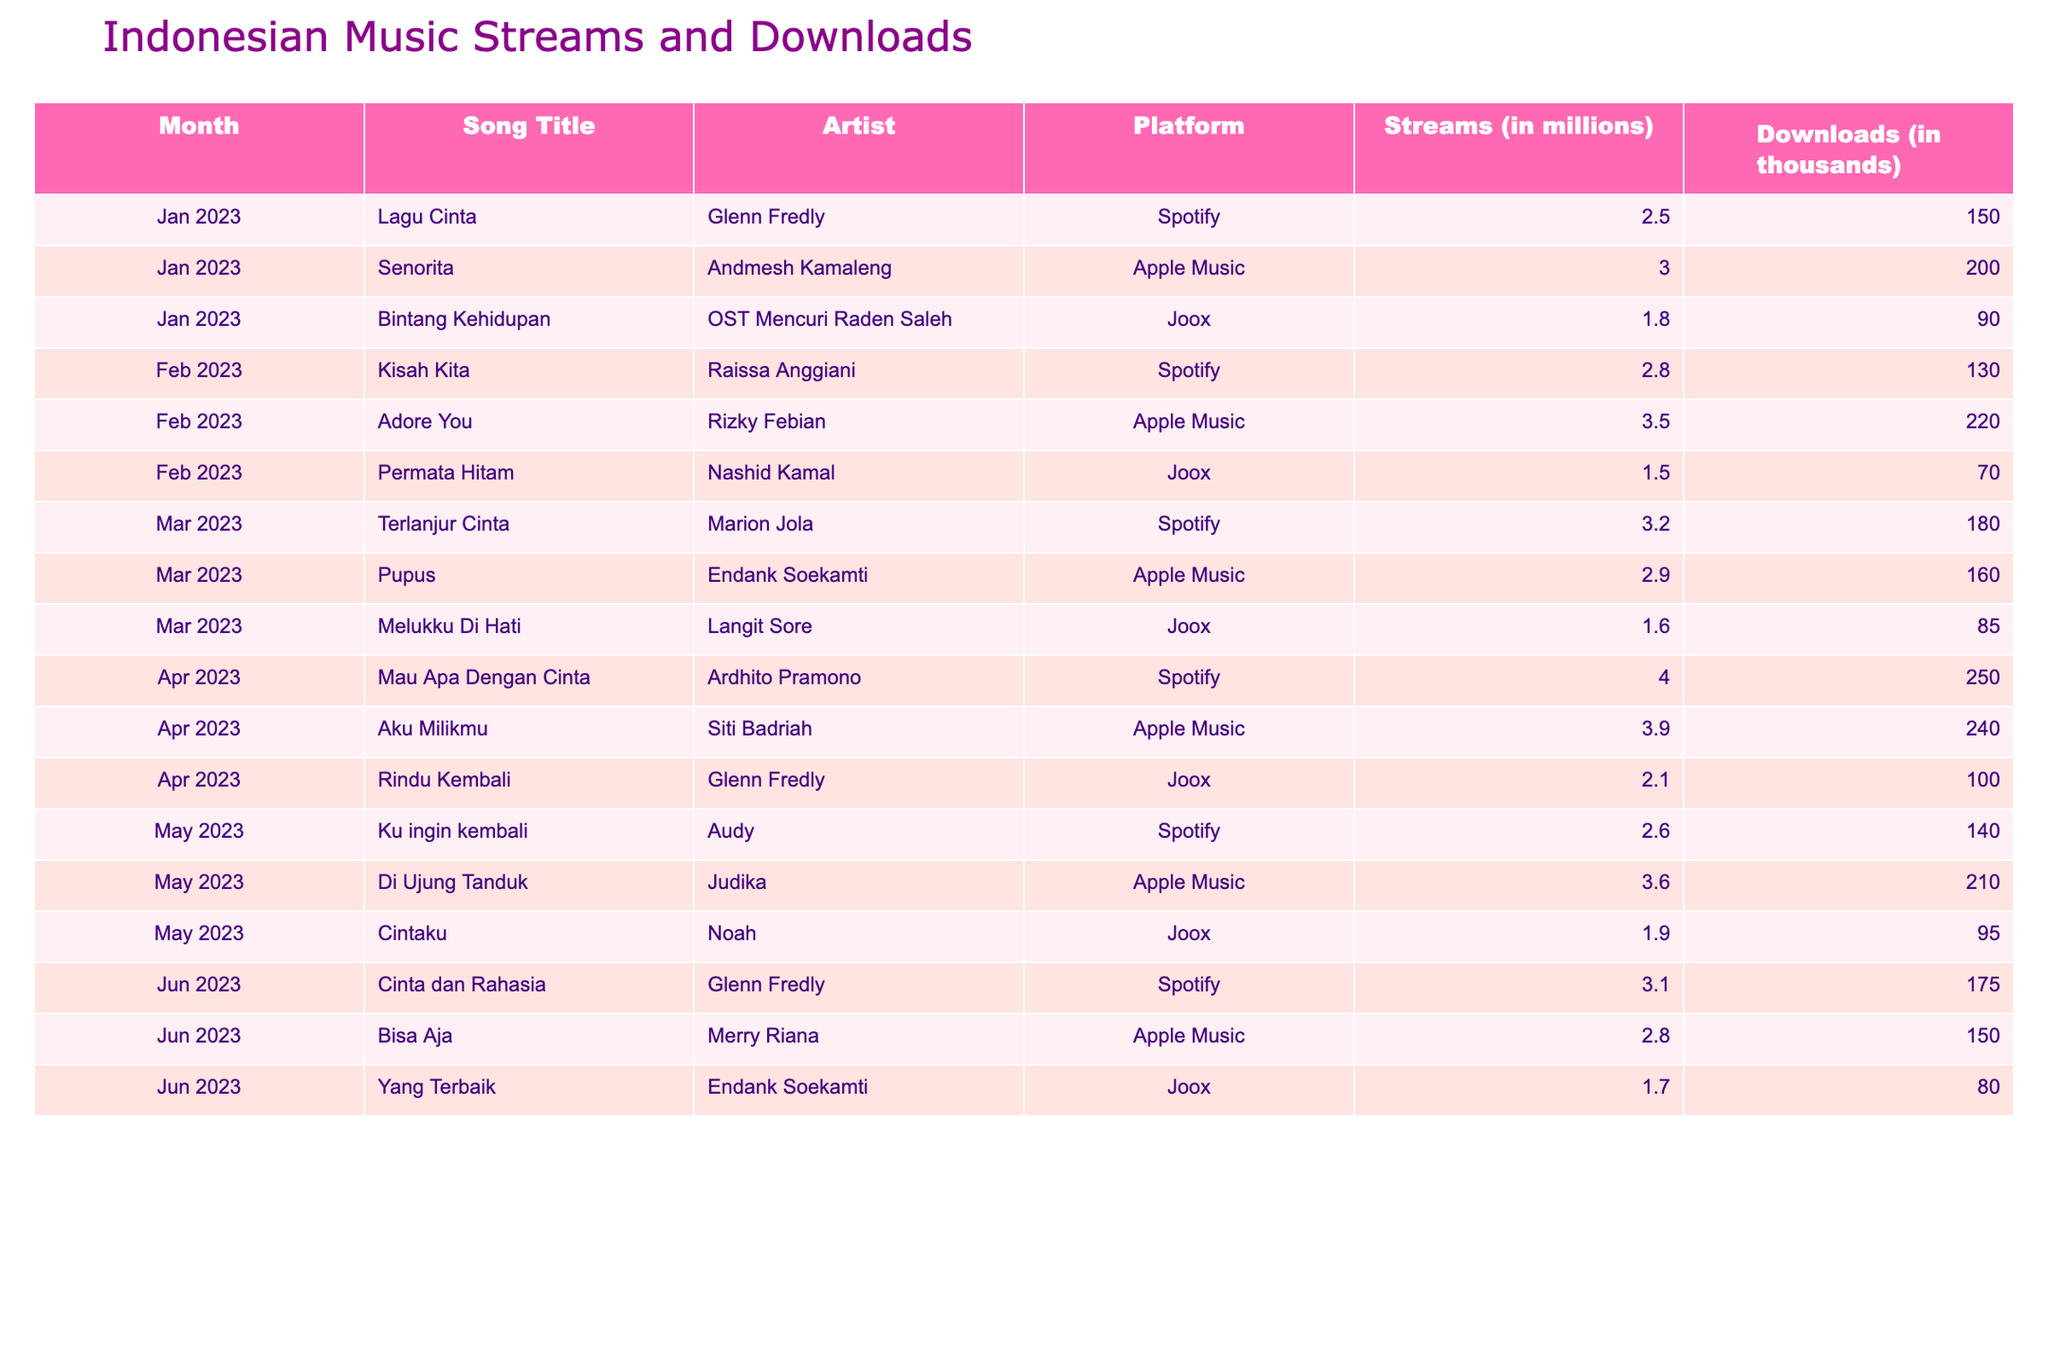What was the most streamed song in April 2023? In April 2023, "Mau Apa Dengan Cinta" by Ardhito Pramono has the highest streams at 4.0 million on Spotify.
Answer: 4.0 million Which song had the highest downloads in May 2023? In May 2023, "Di Ujung Tanduk" by Judika had the highest downloads, totaling 210 thousand.
Answer: 210 thousand What is the average number of streams for songs in February 2023? The streams for February 2023 are 2.8, 3.5, and 1.5 million. Summing these gives 7.8 million, and dividing by 3 gives an average of 2.6 million.
Answer: 2.6 million Did "Cinta dan Rahasia" by Glenn Fredly reach more than 3 million streams? "Cinta dan Rahasia" had 3.1 million streams, which is more than 3 million.
Answer: Yes Which platform had the highest overall downloads for the songs listed? Summing the downloads: Spotify (1,068 thousand), Apple Music (1,060 thousand), and Joox (670 thousand). The highest is Spotify, with 1,068 thousand downloads.
Answer: Spotify What was the total streams across all platforms for songs released in January 2023? The streams for January 2023 are 2.5, 3.0, and 1.8 million. Adding these together, 2.5 + 3.0 + 1.8 equals 7.3 million.
Answer: 7.3 million How many songs had downloads less than 100 thousand in March 2023? In March 2023, only "Melukku Di Hati" had downloads of 85 thousand, which is less than 100 thousand. Therefore, there is 1 song.
Answer: 1 song Which artist has the most appearances in the given data? Glenn Fredly appears in January, April, and June, totaling 3 appearances. Checking other artists, this is the most.
Answer: 3 appearances 